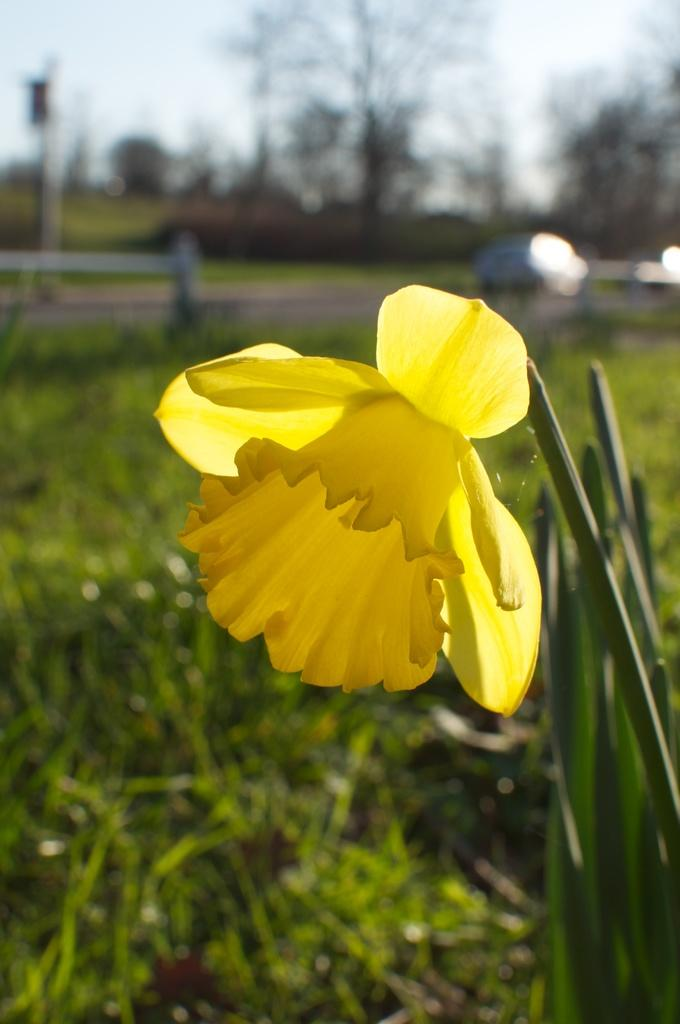What is the main subject of the image? The main subject of the image is a flower. What color is the flower? The flower is yellow. What other parts of the plant are visible in the image? The flower has leaves. What type of vegetation is visible in the image? Grass is visible in the image. How is the background of the image depicted? The background is blurred. What type of bottle is visible in the image? There is no bottle present in the image; it is a close-up of a yellow flower with leaves and grass in the background. Can you tell me how many hours the flower has slept in the image? Flowers do not sleep, so this question cannot be answered. 